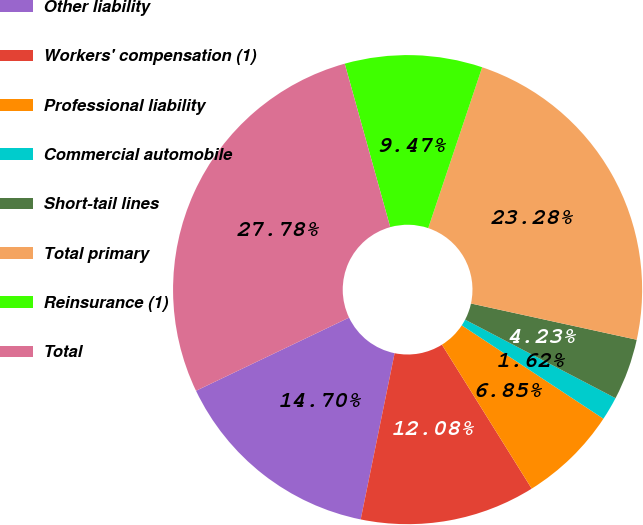<chart> <loc_0><loc_0><loc_500><loc_500><pie_chart><fcel>Other liability<fcel>Workers' compensation (1)<fcel>Professional liability<fcel>Commercial automobile<fcel>Short-tail lines<fcel>Total primary<fcel>Reinsurance (1)<fcel>Total<nl><fcel>14.7%<fcel>12.08%<fcel>6.85%<fcel>1.62%<fcel>4.23%<fcel>23.28%<fcel>9.47%<fcel>27.78%<nl></chart> 